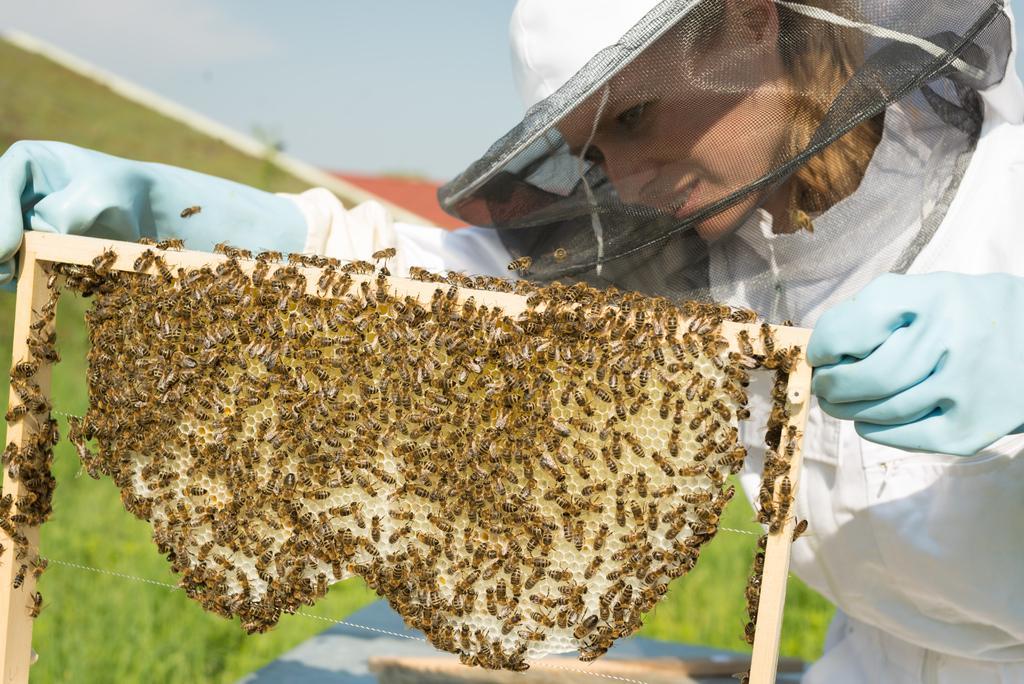Can you describe this image briefly? In this image, we can see a lady wearing a cap, gloves and holding a honeycomb and there are bees on the comb. In the background, there is ground. 